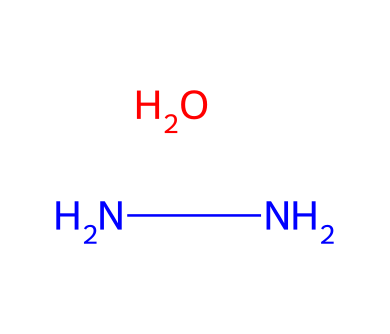What is the primary functional group in this compound? The structure shows two nitrogen atoms and one oxygen atom indicating the presence of a hydrazine functional group (NN-) with an alcohol (O) part.
Answer: hydrazine How many nitrogen atoms are in this compound? By examining the SMILES, we can see two "N" present, indicating that there are two nitrogen atoms in the chemical structure.
Answer: two What type of bonding is primarily exhibited in this compound? The bond between the nitrogen atoms is a single bond ("N-N"), and the bond to oxygen is also a single bond, indicating predominantly single covalent bonds in the molecule.
Answer: single Does this compound contain a hydroxyl (-OH) group? The structure shows an oxygen atom bonded to the nitrogen atoms, indicating that one of the functional parts is a hydroxyl group which defines its behavior as an alcohol.
Answer: yes What is the general use of hydrazines like this in vintage jewelry restoration? The properties of hydrazines, particularly their adhesive capabilities, make them suitable for repairing broken pieces or reattaching stones in vintage costume jewelry.
Answer: adhesion 